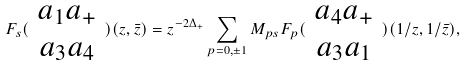<formula> <loc_0><loc_0><loc_500><loc_500>F _ { s } ( \begin{array} { c } a _ { 1 } a _ { + } \\ a _ { 3 } a _ { 4 } \end{array} ) ( z , \bar { z } ) = z ^ { - 2 \Delta _ { + } } \sum _ { p = 0 , \pm 1 } M _ { p s } F _ { p } ( \begin{array} { c } a _ { 4 } a _ { + } \\ a _ { 3 } a _ { 1 } \end{array} ) ( 1 / z , 1 / \bar { z } ) ,</formula> 